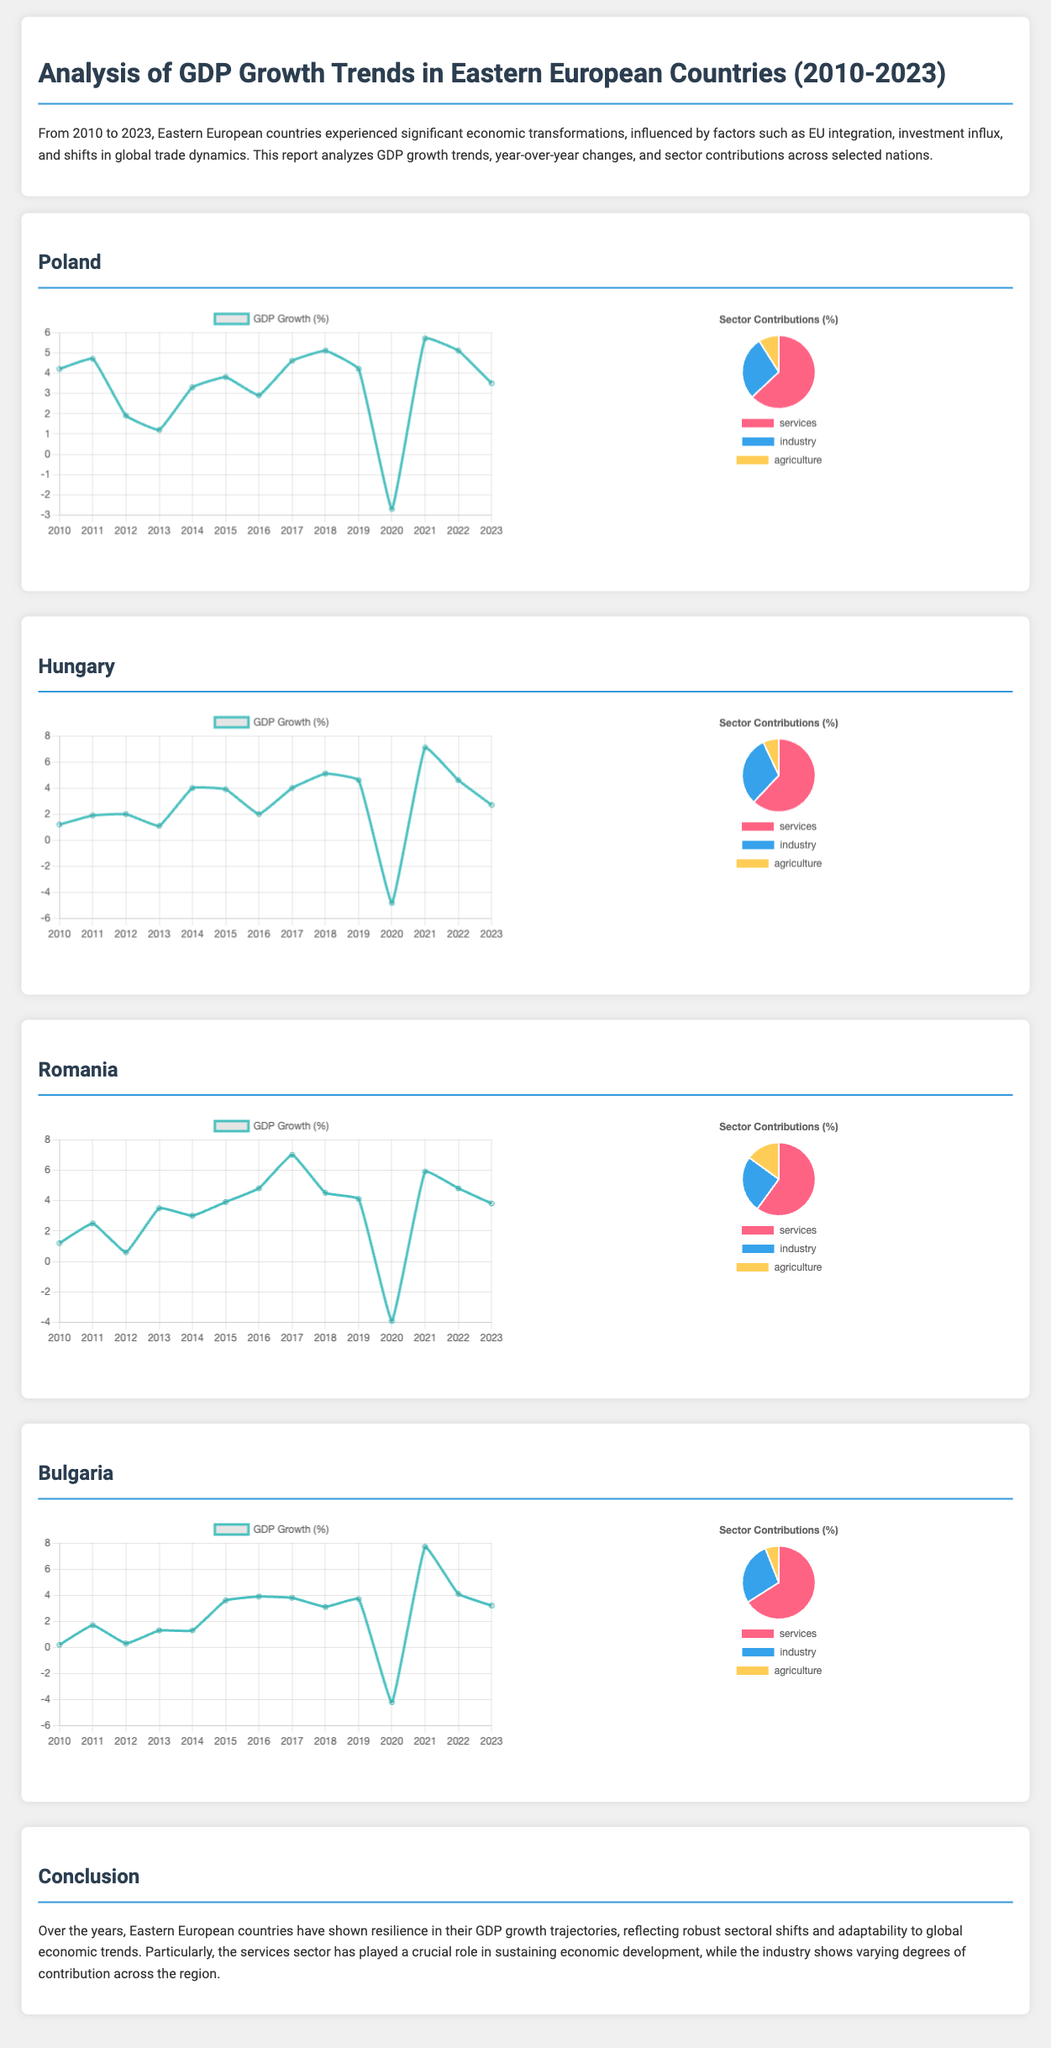What was Poland's GDP growth rate in 2020? The document states Poland's GDP growth rate for 2020 is -2.7%.
Answer: -2.7% Which sector contributes the highest percentage to Hungary's GDP? According to the sector breakdown, services contribute the highest at 62%.
Answer: Services What was Romania's GDP growth in the year 2017? The report indicates that Romania's GDP growth rate for 2017 was 7.0%.
Answer: 7.0% Which year saw the highest GDP growth rate for Bulgaria? The document shows that Bulgaria experienced its highest GDP growth of 7.7% in 2021.
Answer: 7.7% What percentage of GDP does the agriculture sector represent in Poland? The report specifies that agriculture represents 9% of Poland's GDP.
Answer: 9% How did Hungary's GDP growth rate change from 2019 to 2020? It decreased from 4.6% in 2019 to -4.8% in 2020, indicating a significant decline.
Answer: Decreased What is the overall trend in GDP growth for Eastern European countries from 2010 to 2023? The report describes a general resilience in GDP growth trajectories despite variations.
Answer: Resilience What year did Romania experience the lowest GDP growth rate in this report? The document shows that Romania's lowest growth rate was 0.6% in 2012.
Answer: 0.6% Which country had the highest percent contribution from the industry sector? Hungary has the highest contribution from the industry sector at 31%.
Answer: Hungary 